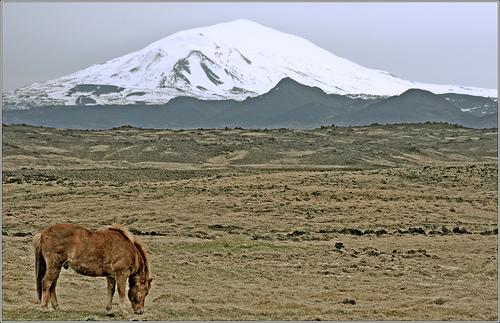Is the horse lonely?
Quick response, please. No. What substance can be seen on the mountain?
Short answer required. Snow. How many animals are shown?
Be succinct. 1. Does this look like any open plain?
Concise answer only. Yes. How many animals in the foreground?
Concise answer only. 1. 